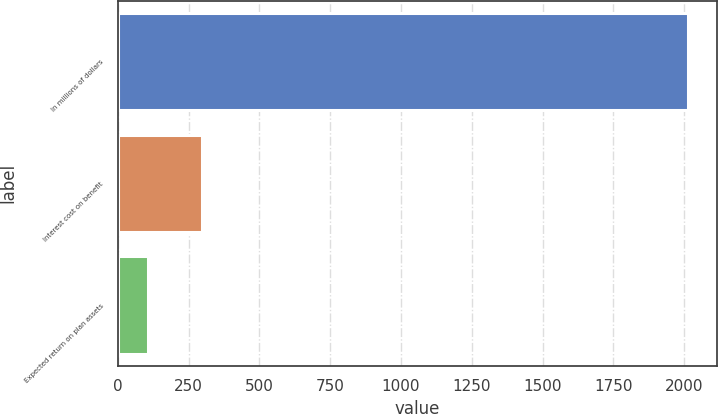Convert chart to OTSL. <chart><loc_0><loc_0><loc_500><loc_500><bar_chart><fcel>In millions of dollars<fcel>Interest cost on benefit<fcel>Expected return on plan assets<nl><fcel>2015<fcel>296<fcel>105<nl></chart> 